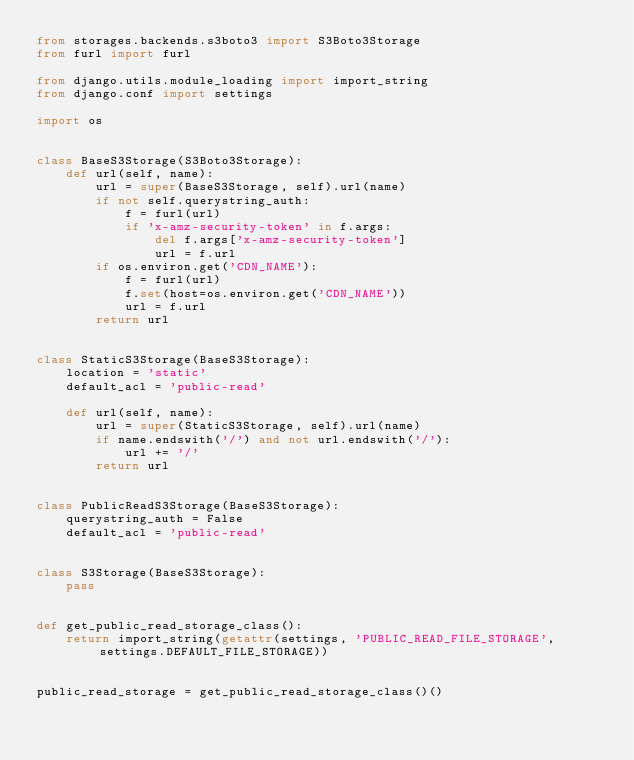Convert code to text. <code><loc_0><loc_0><loc_500><loc_500><_Python_>from storages.backends.s3boto3 import S3Boto3Storage
from furl import furl

from django.utils.module_loading import import_string
from django.conf import settings

import os


class BaseS3Storage(S3Boto3Storage):
    def url(self, name):
        url = super(BaseS3Storage, self).url(name)
        if not self.querystring_auth:
            f = furl(url)
            if 'x-amz-security-token' in f.args:
                del f.args['x-amz-security-token']
                url = f.url
        if os.environ.get('CDN_NAME'):
            f = furl(url)
            f.set(host=os.environ.get('CDN_NAME'))
            url = f.url
        return url


class StaticS3Storage(BaseS3Storage):
    location = 'static'
    default_acl = 'public-read'

    def url(self, name):
        url = super(StaticS3Storage, self).url(name)
        if name.endswith('/') and not url.endswith('/'):
            url += '/'
        return url


class PublicReadS3Storage(BaseS3Storage):
    querystring_auth = False
    default_acl = 'public-read'


class S3Storage(BaseS3Storage):
    pass


def get_public_read_storage_class():
    return import_string(getattr(settings, 'PUBLIC_READ_FILE_STORAGE', settings.DEFAULT_FILE_STORAGE))


public_read_storage = get_public_read_storage_class()()
</code> 